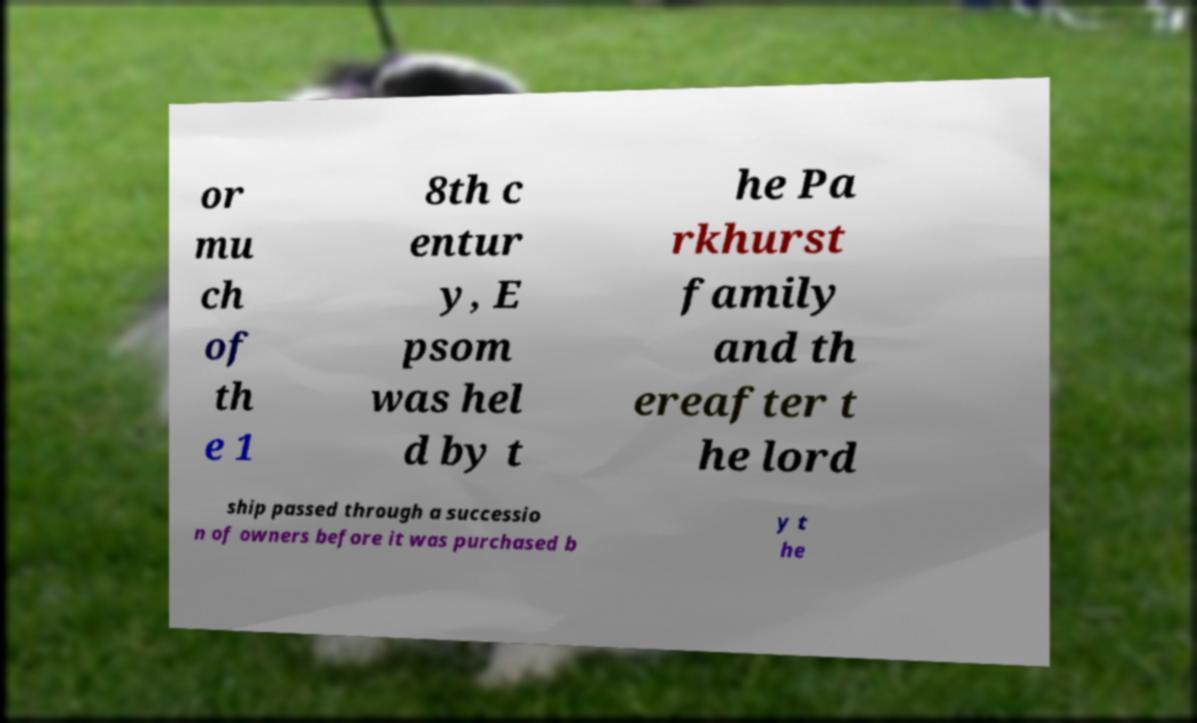I need the written content from this picture converted into text. Can you do that? or mu ch of th e 1 8th c entur y, E psom was hel d by t he Pa rkhurst family and th ereafter t he lord ship passed through a successio n of owners before it was purchased b y t he 